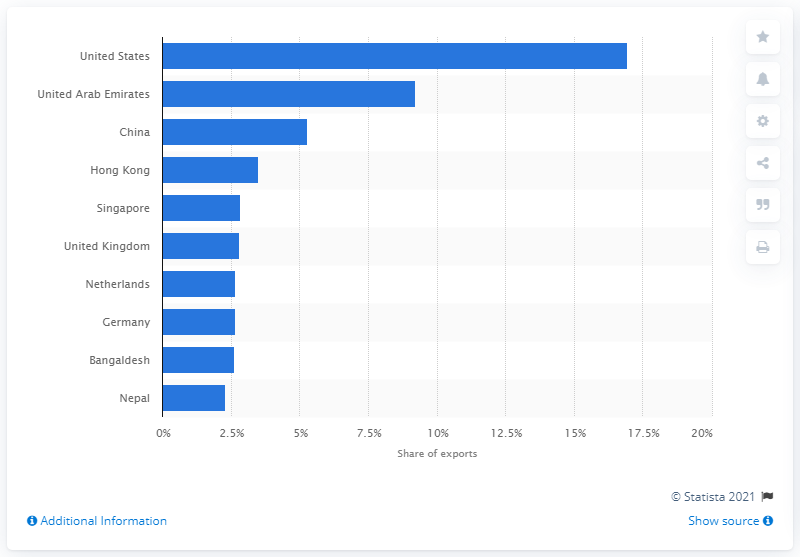Give some essential details in this illustration. A significant portion of India's exports were sourced from China. In fiscal year 2020, 16.95% of Indian exported goods were sourced from the United States. 